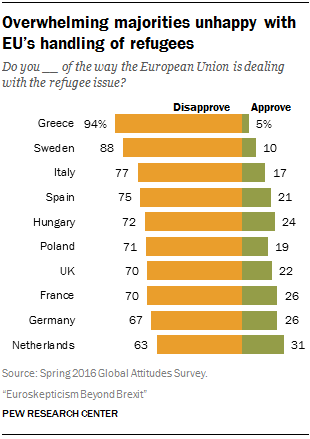Specify some key components in this picture. The ratio (A:B) of occurrences of bars with values 70 and 26 is 0.042361111... According to the survey, 17% of Italian respondents approve of the European Union's handling of the refugee issue. 